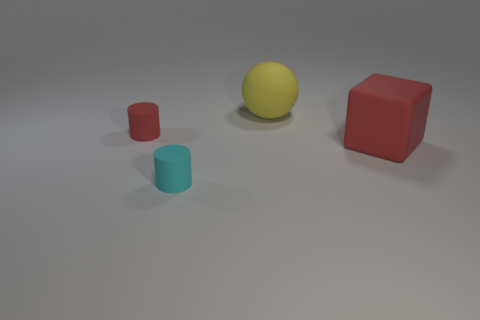Is the number of green metallic blocks greater than the number of big matte balls?
Provide a short and direct response. No. Is there any other thing that has the same size as the yellow matte ball?
Ensure brevity in your answer.  Yes. There is a small object that is behind the big red cube; is it the same shape as the small cyan object?
Give a very brief answer. Yes. Is the number of matte cylinders behind the cyan thing greater than the number of red metallic objects?
Provide a short and direct response. Yes. There is a large thing to the left of the red rubber thing right of the large yellow rubber sphere; what color is it?
Provide a succinct answer. Yellow. What number of big cyan metal balls are there?
Offer a very short reply. 0. What number of things are to the right of the cyan cylinder and in front of the small red rubber cylinder?
Offer a very short reply. 1. Are there any other things that are the same shape as the tiny red object?
Your answer should be very brief. Yes. There is a matte sphere; is its color the same as the tiny object that is in front of the block?
Your answer should be very brief. No. The matte object that is behind the small red matte thing has what shape?
Keep it short and to the point. Sphere. 